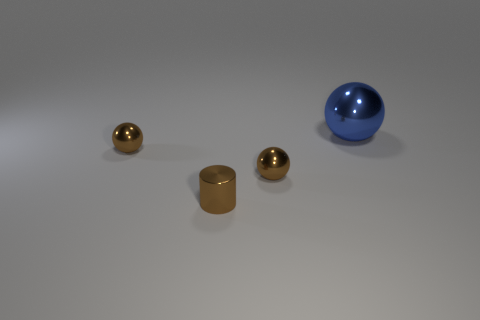What color is the metal thing that is in front of the large blue object and right of the small cylinder?
Make the answer very short. Brown. Is the number of cylinders that are right of the blue metallic ball less than the number of metal spheres in front of the tiny metal cylinder?
Give a very brief answer. No. What number of small metallic things are the same shape as the big blue metal thing?
Your answer should be very brief. 2. What is the size of the cylinder that is made of the same material as the blue ball?
Offer a very short reply. Small. There is a shiny ball that is in front of the brown metallic thing to the left of the brown shiny cylinder; what is its color?
Keep it short and to the point. Brown. Does the big thing have the same shape as the brown thing to the right of the cylinder?
Your response must be concise. Yes. What number of cylinders are the same size as the blue ball?
Your answer should be very brief. 0. There is a tiny metal thing that is on the left side of the brown metal cylinder; is its color the same as the small object that is on the right side of the cylinder?
Offer a very short reply. Yes. The brown thing to the right of the small brown cylinder has what shape?
Your answer should be compact. Sphere. What color is the big metallic ball?
Make the answer very short. Blue. 